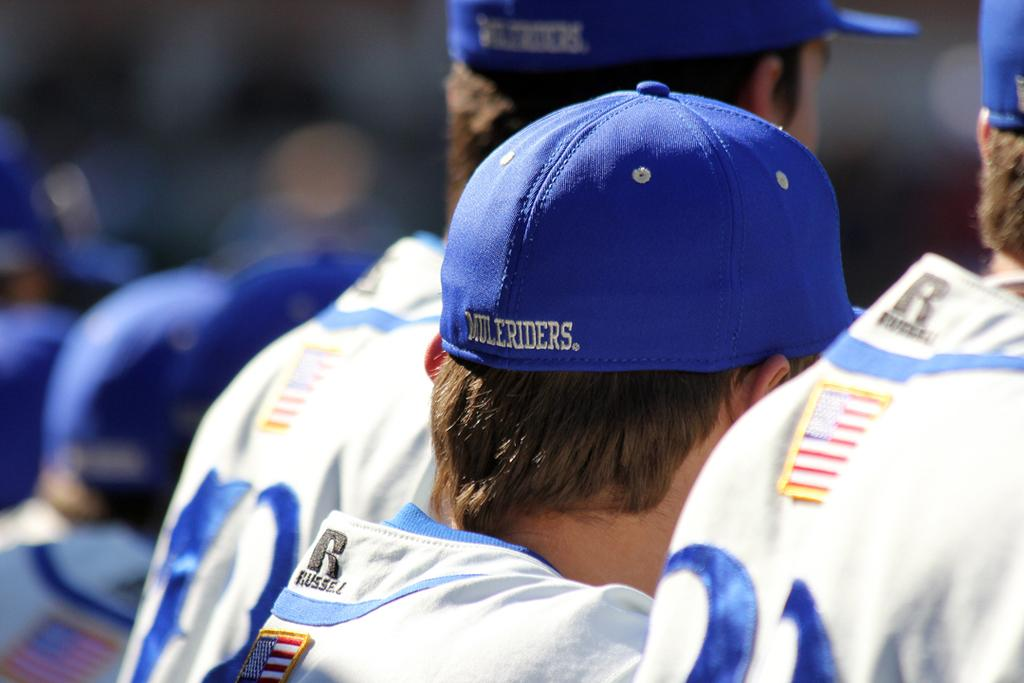Provide a one-sentence caption for the provided image. A man wears a blue hat that reads "Muleriders" on the back. 